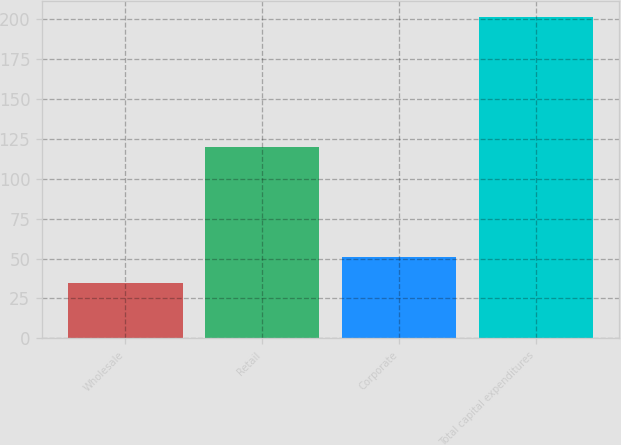Convert chart. <chart><loc_0><loc_0><loc_500><loc_500><bar_chart><fcel>Wholesale<fcel>Retail<fcel>Corporate<fcel>Total capital expenditures<nl><fcel>34.4<fcel>120.1<fcel>51.09<fcel>201.3<nl></chart> 